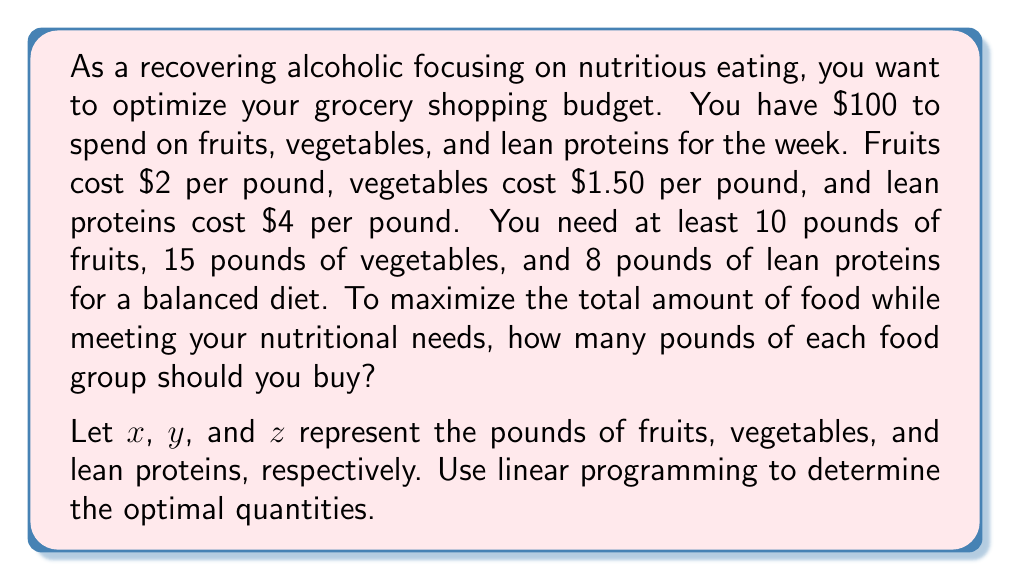Could you help me with this problem? To solve this problem using linear programming, we need to set up the objective function and constraints:

Objective function (maximize total food):
$$\text{Maximize } f(x,y,z) = x + y + z$$

Constraints:
1. Budget constraint: $2x + 1.5y + 4z \leq 100$
2. Minimum fruit requirement: $x \geq 10$
3. Minimum vegetable requirement: $y \geq 15$
4. Minimum lean protein requirement: $z \geq 8$
5. Non-negativity constraints: $x, y, z \geq 0$

We can solve this using the simplex method or graphical method. Let's use the graphical method for visualization:

1. Plot the constraints in the xy-plane, considering z = 8 (minimum protein requirement):
   $2x + 1.5y + 32 \leq 100$
   $2x + 1.5y \leq 68$

2. Plot the minimum requirements for x and y:
   $x \geq 10$
   $y \geq 15$

3. The feasible region is the area that satisfies all constraints.

4. The optimal solution will be at one of the corner points of the feasible region.

5. Evaluate the objective function at each corner point:
   - Point A (10, 15, 8): $f(10, 15, 8) = 33$
   - Point B (10, 32, 8): $f(10, 32, 8) = 50$
   - Point C (17, 15, 8): $f(17, 15, 8) = 40$

6. The optimal solution is at point B (10, 32, 8), which maximizes the total amount of food while meeting all constraints.
Answer: The optimal solution is to buy 10 pounds of fruits, 32 pounds of vegetables, and 8 pounds of lean proteins. This maximizes the total amount of food (50 pounds) while meeting nutritional requirements and staying within the budget. 